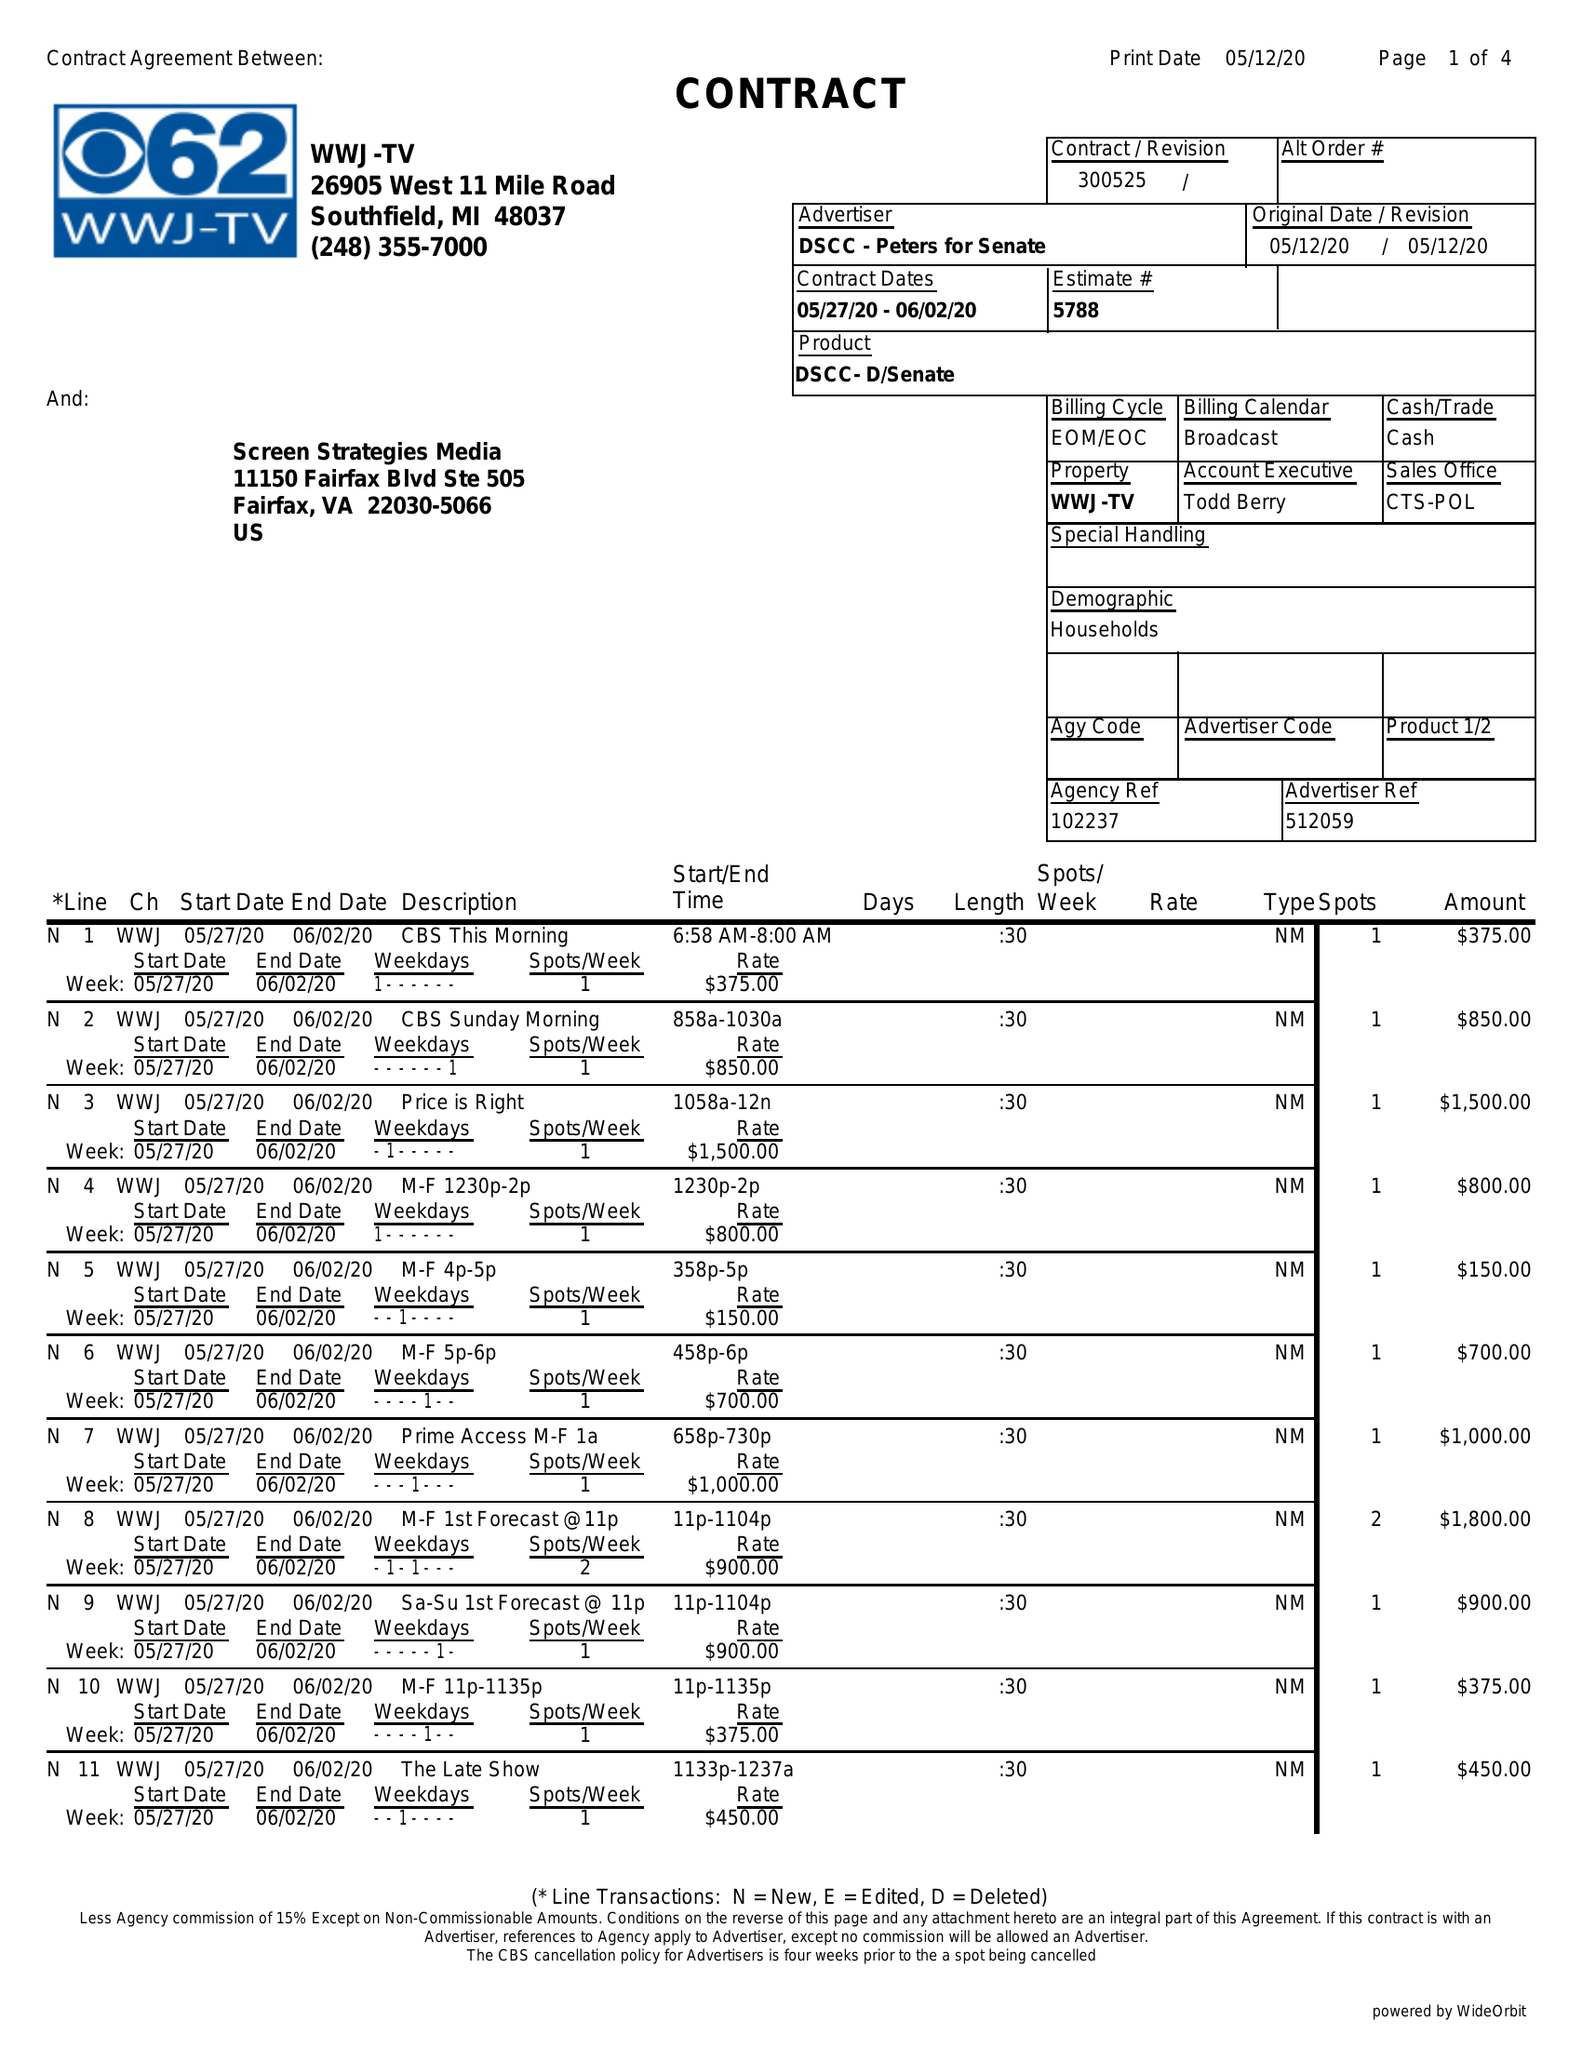What is the value for the gross_amount?
Answer the question using a single word or phrase. 8900.00 